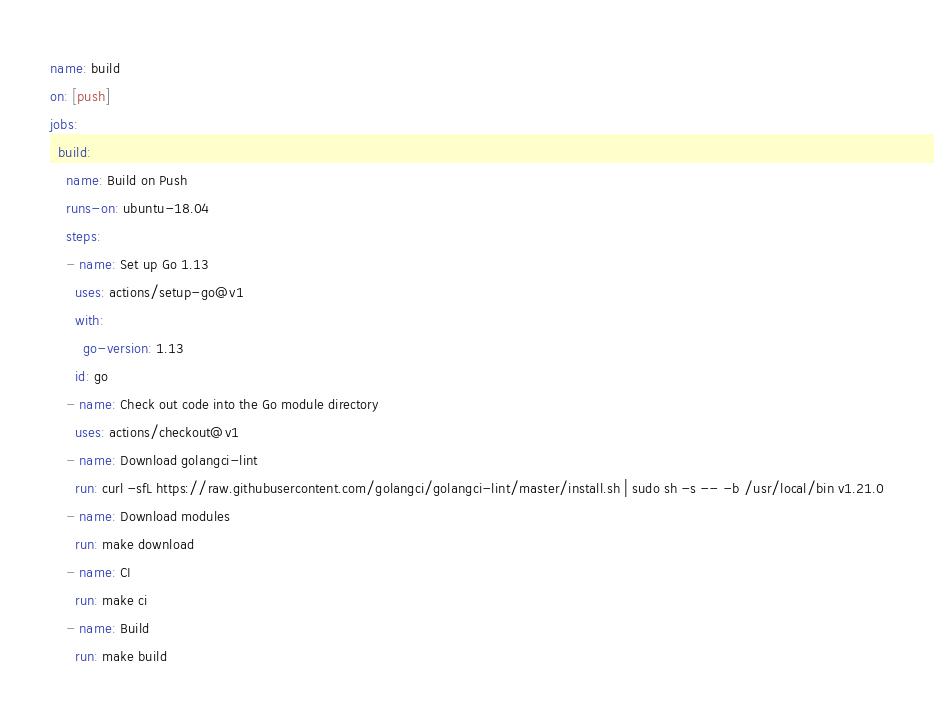<code> <loc_0><loc_0><loc_500><loc_500><_YAML_>name: build
on: [push]
jobs:
  build:
    name: Build on Push
    runs-on: ubuntu-18.04
    steps:
    - name: Set up Go 1.13
      uses: actions/setup-go@v1
      with:
        go-version: 1.13
      id: go
    - name: Check out code into the Go module directory
      uses: actions/checkout@v1
    - name: Download golangci-lint
      run: curl -sfL https://raw.githubusercontent.com/golangci/golangci-lint/master/install.sh | sudo sh -s -- -b /usr/local/bin v1.21.0
    - name: Download modules
      run: make download
    - name: CI
      run: make ci
    - name: Build
      run: make build
</code> 